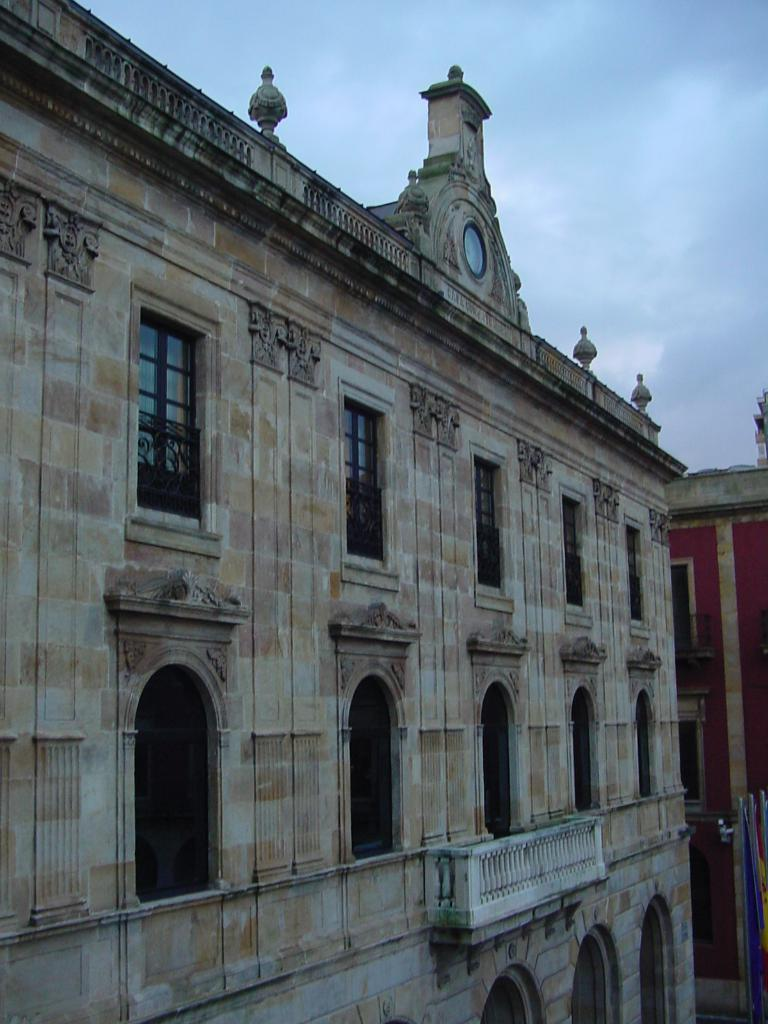What type of structures are present in the image? There are buildings in the image. What are the main features of the buildings? The buildings have walls and windows. What safety feature can be seen in the image? There are railings in the image. What can be seen in the background of the image? The sky is visible in the background of the image. How does the foot affect the buildings in the image? There is no foot present in the image, so it cannot affect the buildings. 